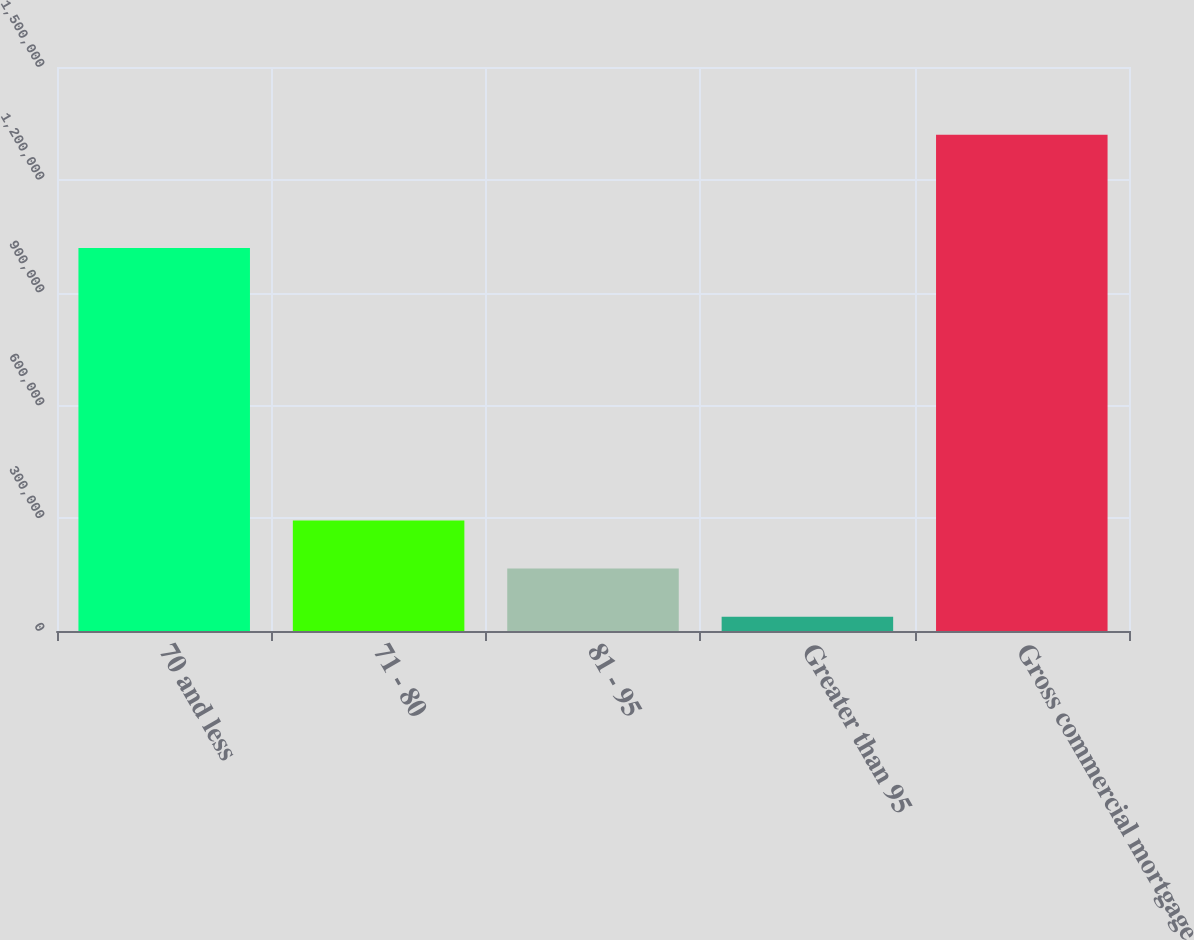Convert chart to OTSL. <chart><loc_0><loc_0><loc_500><loc_500><bar_chart><fcel>70 and less<fcel>71 - 80<fcel>81 - 95<fcel>Greater than 95<fcel>Gross commercial mortgage<nl><fcel>1.01893e+06<fcel>294177<fcel>165937<fcel>37697<fcel>1.3201e+06<nl></chart> 